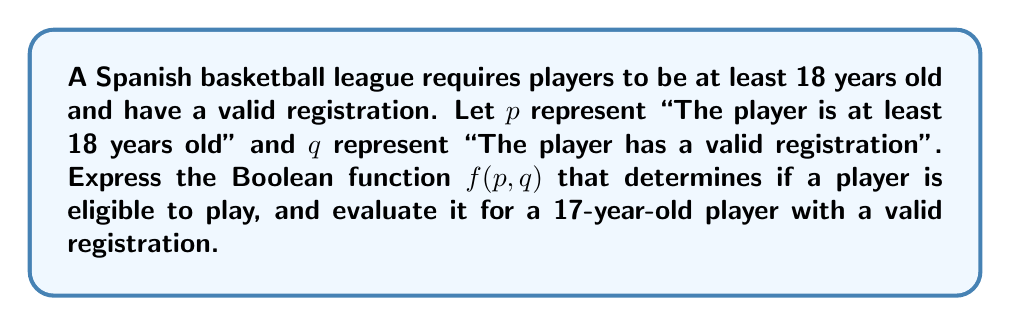Show me your answer to this math problem. 1) First, we need to express the eligibility condition using Boolean logic:
   A player is eligible if they are at least 18 years old AND have a valid registration.
   This can be represented as: $f(p,q) = p \wedge q$

2) Now, let's evaluate this function for the given case:
   - The player is 17 years old, so $p$ is false (0)
   - The player has a valid registration, so $q$ is true (1)

3) Substituting these values into our function:
   $f(p,q) = p \wedge q = 0 \wedge 1$

4) In Boolean algebra, the AND operation ($\wedge$) returns true only if both inputs are true. Otherwise, it returns false.
   $0 \wedge 1 = 0$

5) Therefore, $f(p,q) = 0$, meaning the player is not eligible to play.
Answer: $f(p,q) = p \wedge q = 0$ 